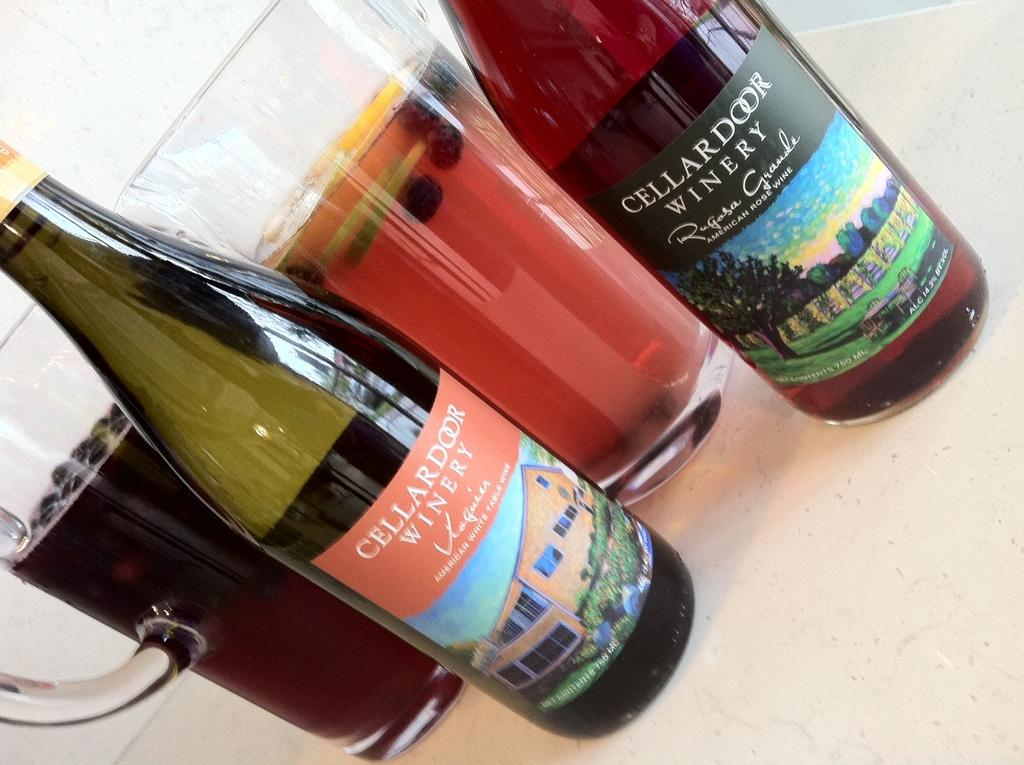<image>
Share a concise interpretation of the image provided. Two differently colored bottles of Cellar door winery branded wine. 